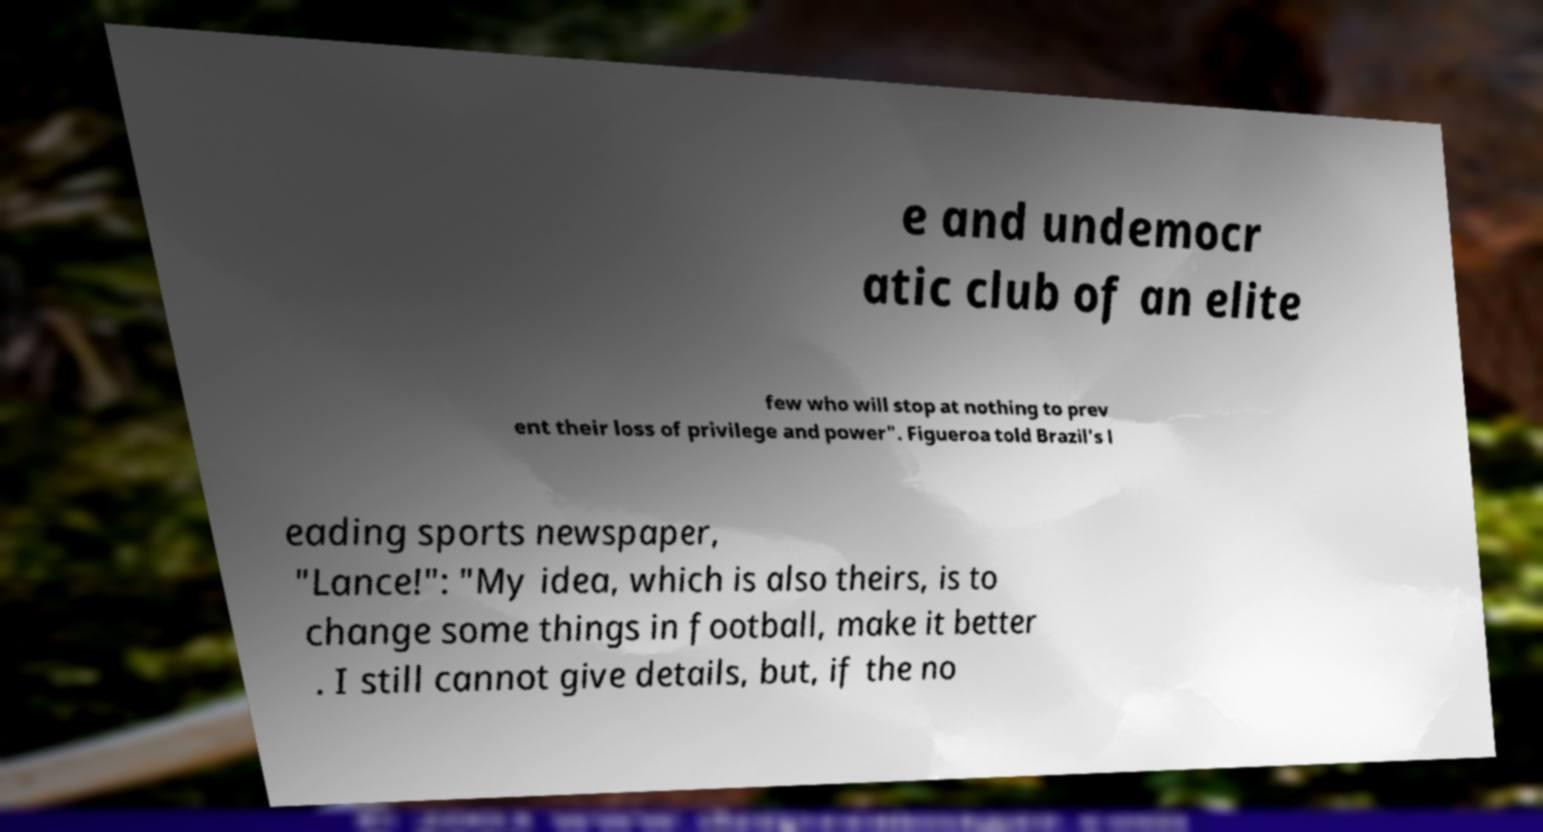What messages or text are displayed in this image? I need them in a readable, typed format. e and undemocr atic club of an elite few who will stop at nothing to prev ent their loss of privilege and power". Figueroa told Brazil's l eading sports newspaper, "Lance!": "My idea, which is also theirs, is to change some things in football, make it better . I still cannot give details, but, if the no 